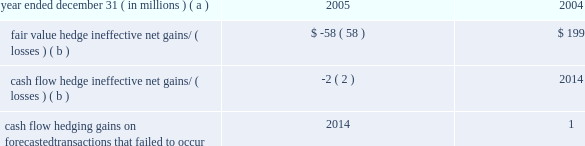Jpmorgan chase & co .
/ 2005 annual report 123 litigation reserve the firm maintains litigation reserves for certain of its litigations , including its material legal proceedings .
While the outcome of litigation is inherently uncertain , management believes , in light of all information known to it at december 31 , 2005 , that the firm 2019s litigation reserves were adequate at such date .
Management reviews litigation reserves periodically , and the reserves may be increased or decreased in the future to reflect further litigation devel- opments .
The firm believes it has meritorious defenses to claims asserted against it in its currently outstanding litigation and , with respect to such liti- gation , intends to continue to defend itself vigorously , litigating or settling cases according to management 2019s judgment as to what is in the best interest of stockholders .
Note 26 2013 accounting for derivative instruments and hedging activities derivative instruments enable end users to increase , reduce or alter exposure to credit or market risks .
The value of a derivative is derived from its reference to an underlying variable or combination of variables such as equity , foreign exchange , credit , commodity or interest rate prices or indices .
Jpmorgan chase makes markets in derivatives for customers and also is an end-user of derivatives in order to manage the firm 2019s exposure to credit and market risks .
Sfas 133 , as amended by sfas 138 and sfas 149 , establishes accounting and reporting standards for derivative instruments , including those used for trading and hedging activities , and derivative instruments embedded in other contracts .
All free-standing derivatives , whether designated for hedging rela- tionships or not , are required to be recorded on the balance sheet at fair value .
The accounting for changes in value of a derivative depends on whether the contract is for trading purposes or has been designated and qualifies for hedge accounting .
The majority of the firm 2019s derivatives are entered into for trading purposes .
The firm also uses derivatives as an end user to hedge market exposures , modify the interest rate characteristics of related balance sheet instruments or meet longer-term investment objectives .
Both trading and end-user derivatives are recorded at fair value in trading assets and trading liabilities as set forth in note 3 on page 94 of this annual report .
In order to qualify for hedge accounting , a derivative must be considered highly effective at reducing the risk associated with the exposure being hedged .
Each derivative must be designated as a hedge , with documentation of the risk management objective and strategy , including identification of the hedging instrument , the hedged item and the risk exposure , and how effectiveness is to be assessed prospectively and retrospectively .
The extent to which a hedging instrument is effective at achieving offsetting changes in fair value or cash flows must be assessed at least quarterly .
Any ineffectiveness must be reported in current-period earnings .
For qualifying fair value hedges , all changes in the fair value of the derivative and in the fair value of the item for the risk being hedged are recognized in earnings .
If the hedge relationship is terminated , then the fair value adjust- ment to the hedged item continues to be reported as part of the basis of the item and is amortized to earnings as a yield adjustment .
For qualifying cash flow hedges , the effective portion of the change in the fair value of the derivative is recorded in other comprehensive income and recognized in the income statement when the hedged cash flows affect earnings .
The ineffective portions of cash flow hedges are immediately recognized in earnings .
If the hedge relationship is terminated , then the change in fair value of the derivative recorded in other comprehensive income is recognized when the cash flows that were hedged occur , consistent with the original hedge strategy .
For hedge relationships discontinued because the forecasted transaction is not expected to occur according to the original strategy , any related derivative amounts recorded in other comprehensive income are immediately recognized in earnings .
For qualifying net investment hedges , changes in the fair value of the derivative or the revaluation of the foreign currency 2013denominated debt instrument are recorded in the translation adjustments account within other comprehensive income .
Any ineffective portions of net investment hedges are immediately recognized in earnings .
Jpmorgan chase 2019s fair value hedges primarily include hedges of fixed-rate long-term debt , loans , afs securities and msrs .
Interest rate swaps are the most common type of derivative contract used to modify exposure to interest rate risk , converting fixed-rate assets and liabilities to a floating rate .
Interest rate options , swaptions and forwards are also used in combination with interest rate swaps to hedge the fair value of the firm 2019s msrs .
For a further discussion of msr risk management activities , see note 15 on pages 114 2013116 of this annual report .
All amounts have been included in earnings consistent with the classification of the hedged item , primarily net interest income , mortgage fees and related income , and other income .
The firm did not recognize any gains or losses during 2005 on firm commitments that no longer qualify as fair value hedges .
Jpmorgan chase also enters into derivative contracts to hedge exposure to variability in cash flows from floating-rate financial instruments and forecasted transactions , primarily the rollover of short-term assets and liabilities , and foreign currency-denominated revenues and expenses .
Interest rate swaps , futures and forward contracts are the most common instruments used to reduce the impact of interest rate and foreign exchange rate changes on future earnings .
All amounts affecting earnings have been recognized consistent with the classification of the hedged item , primarily net interest income .
The firm uses forward foreign exchange contracts and foreign currency- denominated debt instruments to protect the value of net investments in foreign currencies in non-u.s .
Subsidiaries .
The portion of the hedging instru- ments excluded from the assessment of hedge effectiveness ( forward points ) is recorded in net interest income .
The table presents derivative instrument hedging-related activities for the periods indicated : year ended december 31 , ( in millions ) ( a ) 2005 2004 fair value hedge ineffective net gains/ ( losses ) ( b ) $ ( 58 ) $ 199 cash flow hedge ineffective net gains/ ( losses ) ( b ) ( 2 ) 2014 cash flow hedging gains on forecasted transactions that failed to occur 2014 1 ( a ) 2004 results include six months of the combined firm 2019s results and six months of heritage jpmorgan chase results .
( b ) includes ineffectiveness and the components of hedging instruments that have been excluded from the assessment of hedge effectiveness .
Over the next 12 months , it is expected that $ 44 million ( after-tax ) of net gains recorded in other comprehensive income at december 31 , 2005 , will be recognized in earnings .
The maximum length of time over which forecasted transactions are hedged is 10 years , and such transactions primarily relate to core lending and borrowing activities .
Jpmorgan chase does not seek to apply hedge accounting to all of the firm 2019s economic hedges .
For example , the firm does not apply hedge accounting to standard credit derivatives used to manage the credit risk of loans and commitments because of the difficulties in qualifying such contracts as hedges under sfas 133 .
Similarly , the firm does not apply hedge accounting to certain interest rate derivatives used as economic hedges. .
Jpmorgan chase & co .
/ 2005 annual report 123 litigation reserve the firm maintains litigation reserves for certain of its litigations , including its material legal proceedings .
While the outcome of litigation is inherently uncertain , management believes , in light of all information known to it at december 31 , 2005 , that the firm 2019s litigation reserves were adequate at such date .
Management reviews litigation reserves periodically , and the reserves may be increased or decreased in the future to reflect further litigation devel- opments .
The firm believes it has meritorious defenses to claims asserted against it in its currently outstanding litigation and , with respect to such liti- gation , intends to continue to defend itself vigorously , litigating or settling cases according to management 2019s judgment as to what is in the best interest of stockholders .
Note 26 2013 accounting for derivative instruments and hedging activities derivative instruments enable end users to increase , reduce or alter exposure to credit or market risks .
The value of a derivative is derived from its reference to an underlying variable or combination of variables such as equity , foreign exchange , credit , commodity or interest rate prices or indices .
Jpmorgan chase makes markets in derivatives for customers and also is an end-user of derivatives in order to manage the firm 2019s exposure to credit and market risks .
Sfas 133 , as amended by sfas 138 and sfas 149 , establishes accounting and reporting standards for derivative instruments , including those used for trading and hedging activities , and derivative instruments embedded in other contracts .
All free-standing derivatives , whether designated for hedging rela- tionships or not , are required to be recorded on the balance sheet at fair value .
The accounting for changes in value of a derivative depends on whether the contract is for trading purposes or has been designated and qualifies for hedge accounting .
The majority of the firm 2019s derivatives are entered into for trading purposes .
The firm also uses derivatives as an end user to hedge market exposures , modify the interest rate characteristics of related balance sheet instruments or meet longer-term investment objectives .
Both trading and end-user derivatives are recorded at fair value in trading assets and trading liabilities as set forth in note 3 on page 94 of this annual report .
In order to qualify for hedge accounting , a derivative must be considered highly effective at reducing the risk associated with the exposure being hedged .
Each derivative must be designated as a hedge , with documentation of the risk management objective and strategy , including identification of the hedging instrument , the hedged item and the risk exposure , and how effectiveness is to be assessed prospectively and retrospectively .
The extent to which a hedging instrument is effective at achieving offsetting changes in fair value or cash flows must be assessed at least quarterly .
Any ineffectiveness must be reported in current-period earnings .
For qualifying fair value hedges , all changes in the fair value of the derivative and in the fair value of the item for the risk being hedged are recognized in earnings .
If the hedge relationship is terminated , then the fair value adjust- ment to the hedged item continues to be reported as part of the basis of the item and is amortized to earnings as a yield adjustment .
For qualifying cash flow hedges , the effective portion of the change in the fair value of the derivative is recorded in other comprehensive income and recognized in the income statement when the hedged cash flows affect earnings .
The ineffective portions of cash flow hedges are immediately recognized in earnings .
If the hedge relationship is terminated , then the change in fair value of the derivative recorded in other comprehensive income is recognized when the cash flows that were hedged occur , consistent with the original hedge strategy .
For hedge relationships discontinued because the forecasted transaction is not expected to occur according to the original strategy , any related derivative amounts recorded in other comprehensive income are immediately recognized in earnings .
For qualifying net investment hedges , changes in the fair value of the derivative or the revaluation of the foreign currency 2013denominated debt instrument are recorded in the translation adjustments account within other comprehensive income .
Any ineffective portions of net investment hedges are immediately recognized in earnings .
Jpmorgan chase 2019s fair value hedges primarily include hedges of fixed-rate long-term debt , loans , afs securities and msrs .
Interest rate swaps are the most common type of derivative contract used to modify exposure to interest rate risk , converting fixed-rate assets and liabilities to a floating rate .
Interest rate options , swaptions and forwards are also used in combination with interest rate swaps to hedge the fair value of the firm 2019s msrs .
For a further discussion of msr risk management activities , see note 15 on pages 114 2013116 of this annual report .
All amounts have been included in earnings consistent with the classification of the hedged item , primarily net interest income , mortgage fees and related income , and other income .
The firm did not recognize any gains or losses during 2005 on firm commitments that no longer qualify as fair value hedges .
Jpmorgan chase also enters into derivative contracts to hedge exposure to variability in cash flows from floating-rate financial instruments and forecasted transactions , primarily the rollover of short-term assets and liabilities , and foreign currency-denominated revenues and expenses .
Interest rate swaps , futures and forward contracts are the most common instruments used to reduce the impact of interest rate and foreign exchange rate changes on future earnings .
All amounts affecting earnings have been recognized consistent with the classification of the hedged item , primarily net interest income .
The firm uses forward foreign exchange contracts and foreign currency- denominated debt instruments to protect the value of net investments in foreign currencies in non-u.s .
Subsidiaries .
The portion of the hedging instru- ments excluded from the assessment of hedge effectiveness ( forward points ) is recorded in net interest income .
The following table presents derivative instrument hedging-related activities for the periods indicated : year ended december 31 , ( in millions ) ( a ) 2005 2004 fair value hedge ineffective net gains/ ( losses ) ( b ) $ ( 58 ) $ 199 cash flow hedge ineffective net gains/ ( losses ) ( b ) ( 2 ) 2014 cash flow hedging gains on forecasted transactions that failed to occur 2014 1 ( a ) 2004 results include six months of the combined firm 2019s results and six months of heritage jpmorgan chase results .
( b ) includes ineffectiveness and the components of hedging instruments that have been excluded from the assessment of hedge effectiveness .
Over the next 12 months , it is expected that $ 44 million ( after-tax ) of net gains recorded in other comprehensive income at december 31 , 2005 , will be recognized in earnings .
The maximum length of time over which forecasted transactions are hedged is 10 years , and such transactions primarily relate to core lending and borrowing activities .
Jpmorgan chase does not seek to apply hedge accounting to all of the firm 2019s economic hedges .
For example , the firm does not apply hedge accounting to standard credit derivatives used to manage the credit risk of loans and commitments because of the difficulties in qualifying such contracts as hedges under sfas 133 .
Similarly , the firm does not apply hedge accounting to certain interest rate derivatives used as economic hedges. .
For 2005 and 2004 , what were net gains and losses from all hedges ( us$ m? )? 
Computations: (((-58 + 199) + -2) + 1)
Answer: 140.0. 